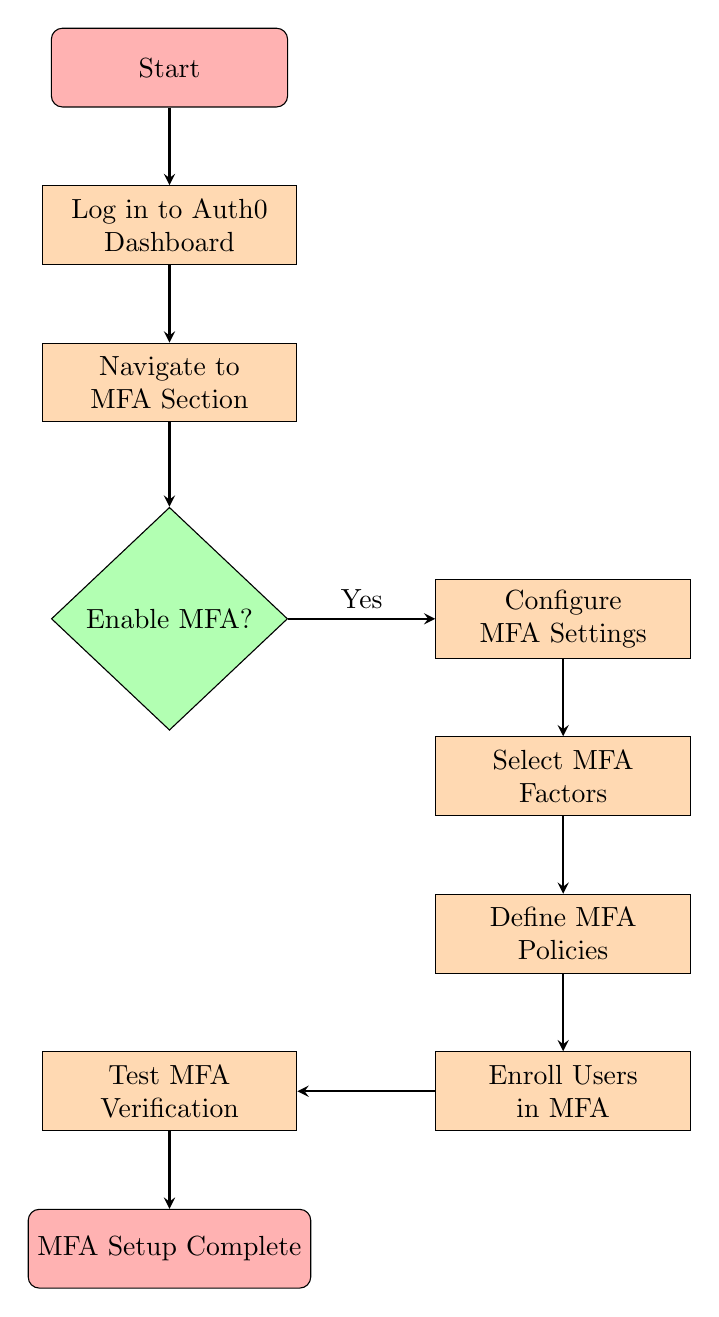What is the first step in the diagram? The diagram starts with the "Start" node, which initiates the flow.
Answer: Start How many decision nodes are in the diagram? There is only one decision node present, which is "Enable MFA?".
Answer: One What happens after navigating to the MFA section? After navigating to the MFA section, the next step is the decision "Enable MFA?".
Answer: Enable MFA? What is the last step in the MFA setup process? The last step is labeled "MFA Setup Complete", which signifies the end of the process.
Answer: MFA Setup Complete What do you do after configuring MFA settings? After configuring MFA settings, the next task is to "Select MFA Factors".
Answer: Select MFA Factors If MFA is not enabled, what is the next step? If MFA is not enabled, the flow would not continue from the decision node, effectively terminating the process.
Answer: None Which step comes directly before user enrollment? The step that comes directly before user enrollment is "Define MFA Policies".
Answer: Define MFA Policies List the various MFA factors that can be selected. The diagram indicates selecting MFA factors, such as SMS or Authenticator App, as potential options in the process.
Answer: SMS, Authenticator App What connects "Users Enroll" to "Test MFA Verification"? The connection from "Users Enroll" to "Test MFA Verification" is through a direct flow indicating the progression of steps in MFA setup.
Answer: Direct flow 